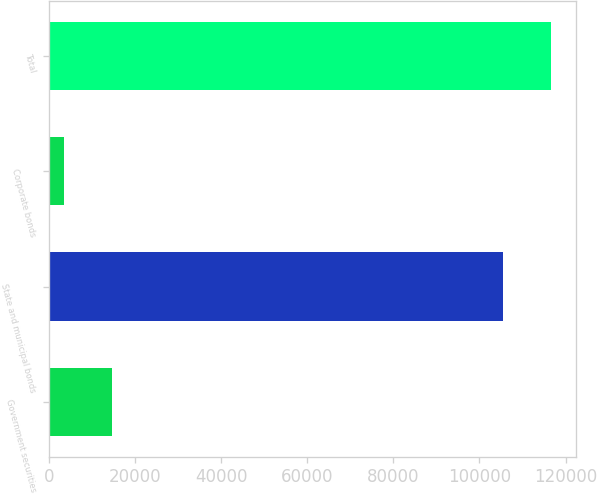Convert chart to OTSL. <chart><loc_0><loc_0><loc_500><loc_500><bar_chart><fcel>Government securities<fcel>State and municipal bonds<fcel>Corporate bonds<fcel>Total<nl><fcel>14697<fcel>105499<fcel>3555<fcel>116641<nl></chart> 